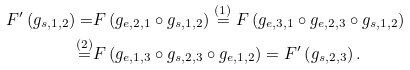Convert formula to latex. <formula><loc_0><loc_0><loc_500><loc_500>F ^ { \prime } \left ( g _ { s , 1 , 2 } \right ) = & F \left ( g _ { e , 2 , 1 } \circ g _ { s , 1 , 2 } \right ) \overset { ( 1 ) } { = } F \left ( g _ { e , 3 , 1 } \circ g _ { e , 2 , 3 } \circ g _ { s , 1 , 2 } \right ) \\ \overset { ( 2 ) } { = } & F \left ( g _ { e , 1 , 3 } \circ g _ { s , 2 , 3 } \circ g _ { e , 1 , 2 } \right ) = F ^ { \prime } \left ( g _ { s , 2 , 3 } \right ) .</formula> 